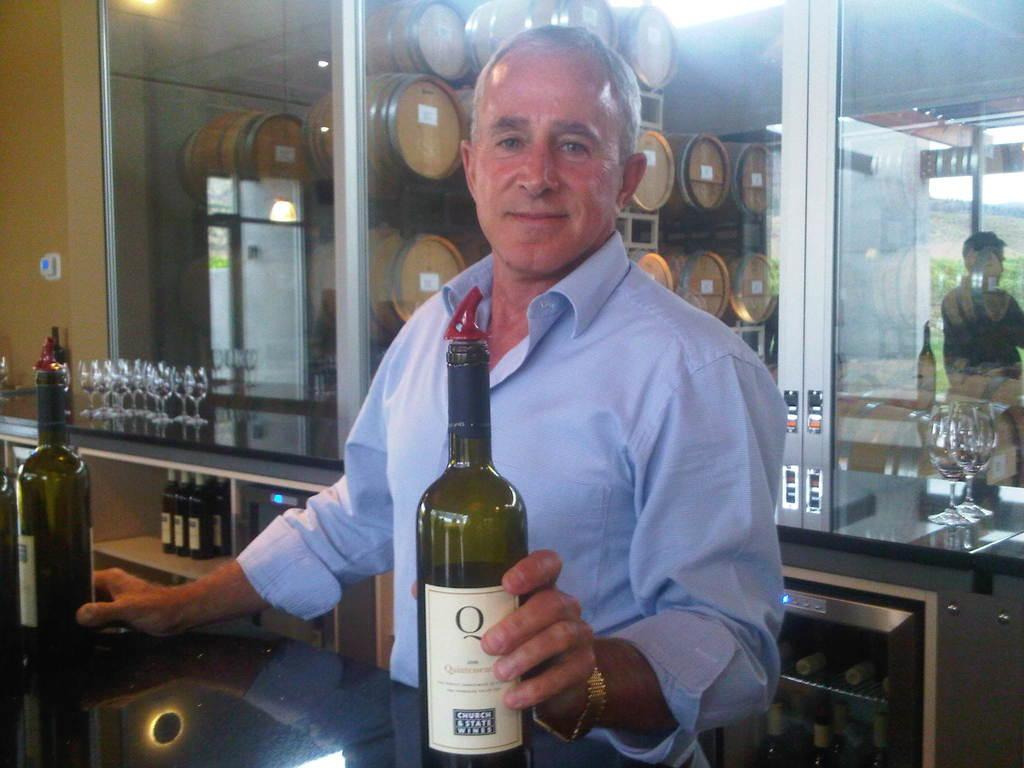<image>
Share a concise interpretation of the image provided. the word Q that is on a bottle 